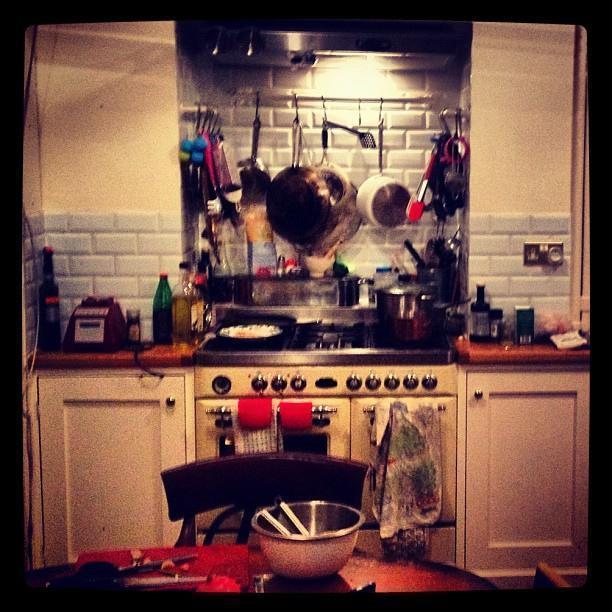What items are found on the wall?
Select the accurate answer and provide explanation: 'Answer: answer
Rationale: rationale.'
Options: Posters, hams, pots, sausages. Answer: pots.
Rationale: The pots are usually kept by the stove which are used to cook. 